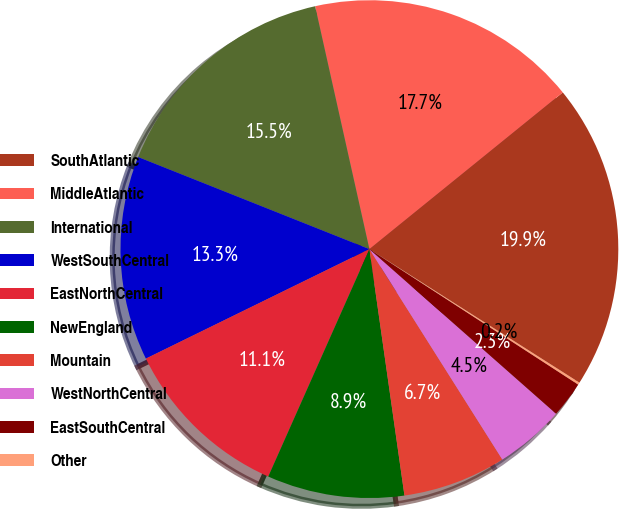Convert chart to OTSL. <chart><loc_0><loc_0><loc_500><loc_500><pie_chart><fcel>SouthAtlantic<fcel>MiddleAtlantic<fcel>International<fcel>WestSouthCentral<fcel>EastNorthCentral<fcel>NewEngland<fcel>Mountain<fcel>WestNorthCentral<fcel>EastSouthCentral<fcel>Other<nl><fcel>19.85%<fcel>17.66%<fcel>15.47%<fcel>13.28%<fcel>11.09%<fcel>8.91%<fcel>6.72%<fcel>4.53%<fcel>2.34%<fcel>0.15%<nl></chart> 